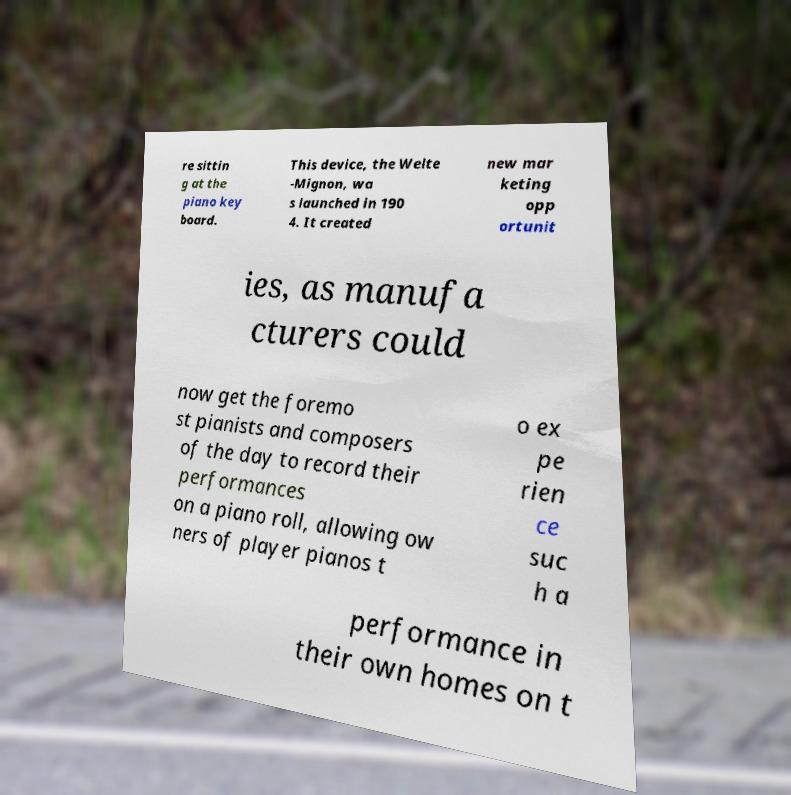For documentation purposes, I need the text within this image transcribed. Could you provide that? re sittin g at the piano key board. This device, the Welte -Mignon, wa s launched in 190 4. It created new mar keting opp ortunit ies, as manufa cturers could now get the foremo st pianists and composers of the day to record their performances on a piano roll, allowing ow ners of player pianos t o ex pe rien ce suc h a performance in their own homes on t 